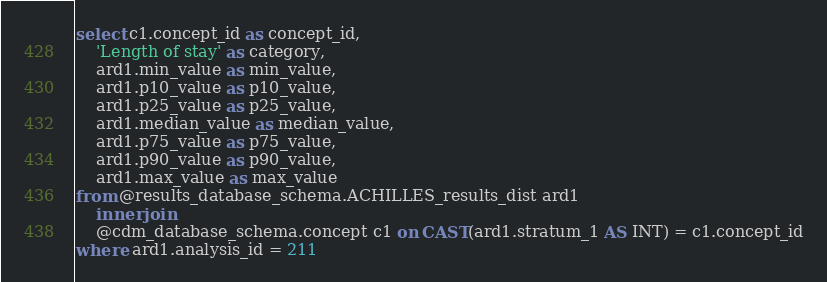<code> <loc_0><loc_0><loc_500><loc_500><_SQL_>select c1.concept_id as concept_id,
	'Length of stay' as category,
	ard1.min_value as min_value,
	ard1.p10_value as p10_value,
	ard1.p25_value as p25_value,
	ard1.median_value as median_value,
	ard1.p75_value as p75_value,
	ard1.p90_value as p90_value,
	ard1.max_value as max_value
from @results_database_schema.ACHILLES_results_dist ard1
	inner join
	@cdm_database_schema.concept c1 on CAST(ard1.stratum_1 AS INT) = c1.concept_id
where ard1.analysis_id = 211
</code> 